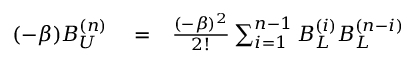<formula> <loc_0><loc_0><loc_500><loc_500>\begin{array} { r l r } { ( - \beta ) B _ { U } ^ { ( n ) } } & = } & { \frac { ( - \beta ) ^ { 2 } } { 2 ! } \sum _ { i = 1 } ^ { n - 1 } B _ { L } ^ { ( i ) } B _ { L } ^ { ( n - i ) } } \end{array}</formula> 